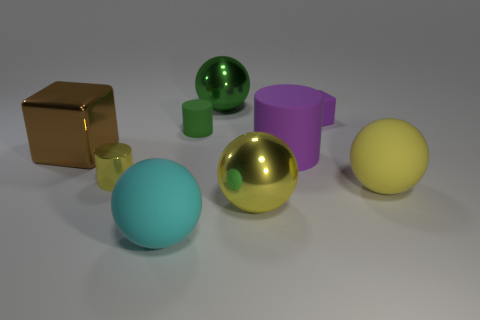Is the rubber cube the same color as the big rubber cylinder?
Provide a short and direct response. Yes. There is a sphere that is the same color as the small matte cylinder; what is its material?
Ensure brevity in your answer.  Metal. There is a tiny block that is made of the same material as the green cylinder; what color is it?
Keep it short and to the point. Purple. There is a sphere to the left of the tiny matte thing on the left side of the big metallic sphere that is in front of the large cube; what is its material?
Keep it short and to the point. Rubber. There is a green thing behind the purple rubber block; is it the same size as the rubber cube?
Offer a terse response. No. How many small things are green metallic things or blue rubber blocks?
Offer a terse response. 0. Is there a block of the same color as the small shiny thing?
Your answer should be very brief. No. What shape is the purple object that is the same size as the yellow shiny cylinder?
Your answer should be very brief. Cube. Does the metal thing that is on the right side of the large green metal thing have the same color as the large cube?
Keep it short and to the point. No. What number of objects are either large matte balls that are to the left of the tiny rubber cylinder or small brown metallic spheres?
Provide a short and direct response. 1. 